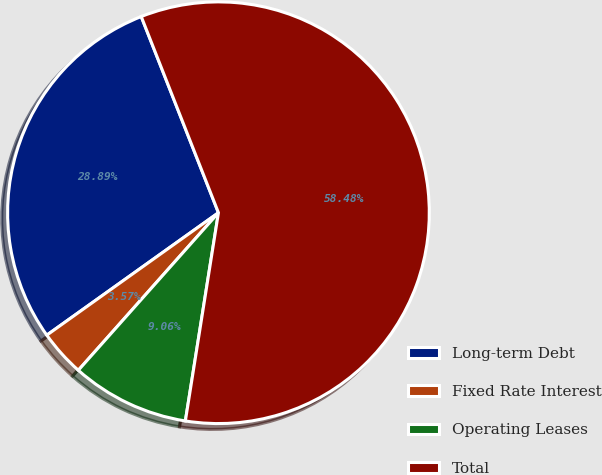Convert chart to OTSL. <chart><loc_0><loc_0><loc_500><loc_500><pie_chart><fcel>Long-term Debt<fcel>Fixed Rate Interest<fcel>Operating Leases<fcel>Total<nl><fcel>28.89%<fcel>3.57%<fcel>9.06%<fcel>58.47%<nl></chart> 